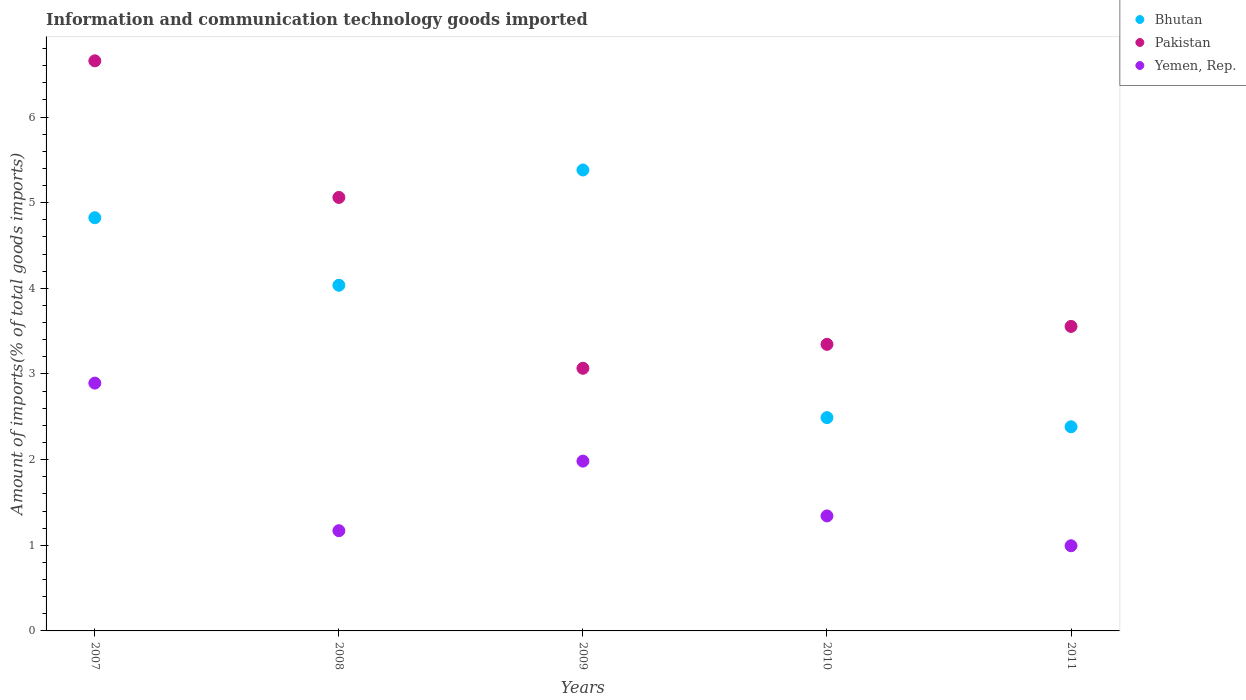What is the amount of goods imported in Yemen, Rep. in 2011?
Give a very brief answer. 0.99. Across all years, what is the maximum amount of goods imported in Bhutan?
Offer a terse response. 5.38. Across all years, what is the minimum amount of goods imported in Yemen, Rep.?
Your response must be concise. 0.99. In which year was the amount of goods imported in Bhutan minimum?
Your response must be concise. 2011. What is the total amount of goods imported in Yemen, Rep. in the graph?
Your response must be concise. 8.38. What is the difference between the amount of goods imported in Bhutan in 2008 and that in 2010?
Make the answer very short. 1.55. What is the difference between the amount of goods imported in Yemen, Rep. in 2008 and the amount of goods imported in Pakistan in 2010?
Keep it short and to the point. -2.18. What is the average amount of goods imported in Bhutan per year?
Make the answer very short. 3.82. In the year 2007, what is the difference between the amount of goods imported in Yemen, Rep. and amount of goods imported in Pakistan?
Give a very brief answer. -3.76. In how many years, is the amount of goods imported in Pakistan greater than 1 %?
Make the answer very short. 5. What is the ratio of the amount of goods imported in Yemen, Rep. in 2007 to that in 2008?
Make the answer very short. 2.47. Is the difference between the amount of goods imported in Yemen, Rep. in 2007 and 2011 greater than the difference between the amount of goods imported in Pakistan in 2007 and 2011?
Offer a very short reply. No. What is the difference between the highest and the second highest amount of goods imported in Bhutan?
Make the answer very short. 0.56. What is the difference between the highest and the lowest amount of goods imported in Yemen, Rep.?
Your response must be concise. 1.9. In how many years, is the amount of goods imported in Pakistan greater than the average amount of goods imported in Pakistan taken over all years?
Give a very brief answer. 2. Is the sum of the amount of goods imported in Pakistan in 2008 and 2011 greater than the maximum amount of goods imported in Bhutan across all years?
Ensure brevity in your answer.  Yes. Does the amount of goods imported in Pakistan monotonically increase over the years?
Your answer should be very brief. No. Is the amount of goods imported in Bhutan strictly greater than the amount of goods imported in Yemen, Rep. over the years?
Offer a terse response. Yes. Where does the legend appear in the graph?
Provide a succinct answer. Top right. How are the legend labels stacked?
Provide a succinct answer. Vertical. What is the title of the graph?
Give a very brief answer. Information and communication technology goods imported. What is the label or title of the X-axis?
Ensure brevity in your answer.  Years. What is the label or title of the Y-axis?
Ensure brevity in your answer.  Amount of imports(% of total goods imports). What is the Amount of imports(% of total goods imports) of Bhutan in 2007?
Keep it short and to the point. 4.82. What is the Amount of imports(% of total goods imports) of Pakistan in 2007?
Give a very brief answer. 6.66. What is the Amount of imports(% of total goods imports) in Yemen, Rep. in 2007?
Your response must be concise. 2.89. What is the Amount of imports(% of total goods imports) in Bhutan in 2008?
Provide a short and direct response. 4.04. What is the Amount of imports(% of total goods imports) of Pakistan in 2008?
Your answer should be very brief. 5.06. What is the Amount of imports(% of total goods imports) of Yemen, Rep. in 2008?
Provide a succinct answer. 1.17. What is the Amount of imports(% of total goods imports) of Bhutan in 2009?
Offer a terse response. 5.38. What is the Amount of imports(% of total goods imports) in Pakistan in 2009?
Make the answer very short. 3.07. What is the Amount of imports(% of total goods imports) of Yemen, Rep. in 2009?
Keep it short and to the point. 1.98. What is the Amount of imports(% of total goods imports) of Bhutan in 2010?
Your answer should be very brief. 2.49. What is the Amount of imports(% of total goods imports) in Pakistan in 2010?
Your answer should be compact. 3.35. What is the Amount of imports(% of total goods imports) of Yemen, Rep. in 2010?
Give a very brief answer. 1.34. What is the Amount of imports(% of total goods imports) in Bhutan in 2011?
Make the answer very short. 2.38. What is the Amount of imports(% of total goods imports) of Pakistan in 2011?
Offer a terse response. 3.56. What is the Amount of imports(% of total goods imports) of Yemen, Rep. in 2011?
Provide a short and direct response. 0.99. Across all years, what is the maximum Amount of imports(% of total goods imports) of Bhutan?
Offer a very short reply. 5.38. Across all years, what is the maximum Amount of imports(% of total goods imports) in Pakistan?
Make the answer very short. 6.66. Across all years, what is the maximum Amount of imports(% of total goods imports) of Yemen, Rep.?
Make the answer very short. 2.89. Across all years, what is the minimum Amount of imports(% of total goods imports) of Bhutan?
Offer a very short reply. 2.38. Across all years, what is the minimum Amount of imports(% of total goods imports) in Pakistan?
Provide a short and direct response. 3.07. Across all years, what is the minimum Amount of imports(% of total goods imports) in Yemen, Rep.?
Provide a succinct answer. 0.99. What is the total Amount of imports(% of total goods imports) of Bhutan in the graph?
Offer a terse response. 19.12. What is the total Amount of imports(% of total goods imports) in Pakistan in the graph?
Give a very brief answer. 21.69. What is the total Amount of imports(% of total goods imports) of Yemen, Rep. in the graph?
Offer a very short reply. 8.38. What is the difference between the Amount of imports(% of total goods imports) of Bhutan in 2007 and that in 2008?
Keep it short and to the point. 0.79. What is the difference between the Amount of imports(% of total goods imports) of Pakistan in 2007 and that in 2008?
Your answer should be compact. 1.6. What is the difference between the Amount of imports(% of total goods imports) in Yemen, Rep. in 2007 and that in 2008?
Provide a succinct answer. 1.72. What is the difference between the Amount of imports(% of total goods imports) of Bhutan in 2007 and that in 2009?
Ensure brevity in your answer.  -0.56. What is the difference between the Amount of imports(% of total goods imports) of Pakistan in 2007 and that in 2009?
Ensure brevity in your answer.  3.59. What is the difference between the Amount of imports(% of total goods imports) in Yemen, Rep. in 2007 and that in 2009?
Your answer should be very brief. 0.91. What is the difference between the Amount of imports(% of total goods imports) in Bhutan in 2007 and that in 2010?
Your response must be concise. 2.33. What is the difference between the Amount of imports(% of total goods imports) of Pakistan in 2007 and that in 2010?
Provide a succinct answer. 3.31. What is the difference between the Amount of imports(% of total goods imports) in Yemen, Rep. in 2007 and that in 2010?
Give a very brief answer. 1.55. What is the difference between the Amount of imports(% of total goods imports) of Bhutan in 2007 and that in 2011?
Give a very brief answer. 2.44. What is the difference between the Amount of imports(% of total goods imports) in Pakistan in 2007 and that in 2011?
Provide a short and direct response. 3.1. What is the difference between the Amount of imports(% of total goods imports) of Yemen, Rep. in 2007 and that in 2011?
Provide a succinct answer. 1.9. What is the difference between the Amount of imports(% of total goods imports) of Bhutan in 2008 and that in 2009?
Keep it short and to the point. -1.35. What is the difference between the Amount of imports(% of total goods imports) in Pakistan in 2008 and that in 2009?
Offer a terse response. 1.99. What is the difference between the Amount of imports(% of total goods imports) in Yemen, Rep. in 2008 and that in 2009?
Offer a very short reply. -0.81. What is the difference between the Amount of imports(% of total goods imports) of Bhutan in 2008 and that in 2010?
Your response must be concise. 1.55. What is the difference between the Amount of imports(% of total goods imports) in Pakistan in 2008 and that in 2010?
Make the answer very short. 1.72. What is the difference between the Amount of imports(% of total goods imports) of Yemen, Rep. in 2008 and that in 2010?
Your answer should be very brief. -0.17. What is the difference between the Amount of imports(% of total goods imports) in Bhutan in 2008 and that in 2011?
Provide a succinct answer. 1.65. What is the difference between the Amount of imports(% of total goods imports) of Pakistan in 2008 and that in 2011?
Make the answer very short. 1.51. What is the difference between the Amount of imports(% of total goods imports) in Yemen, Rep. in 2008 and that in 2011?
Offer a terse response. 0.18. What is the difference between the Amount of imports(% of total goods imports) in Bhutan in 2009 and that in 2010?
Keep it short and to the point. 2.89. What is the difference between the Amount of imports(% of total goods imports) in Pakistan in 2009 and that in 2010?
Offer a terse response. -0.28. What is the difference between the Amount of imports(% of total goods imports) in Yemen, Rep. in 2009 and that in 2010?
Offer a very short reply. 0.64. What is the difference between the Amount of imports(% of total goods imports) in Bhutan in 2009 and that in 2011?
Offer a terse response. 3. What is the difference between the Amount of imports(% of total goods imports) in Pakistan in 2009 and that in 2011?
Your answer should be very brief. -0.49. What is the difference between the Amount of imports(% of total goods imports) of Bhutan in 2010 and that in 2011?
Your response must be concise. 0.11. What is the difference between the Amount of imports(% of total goods imports) in Pakistan in 2010 and that in 2011?
Provide a succinct answer. -0.21. What is the difference between the Amount of imports(% of total goods imports) in Yemen, Rep. in 2010 and that in 2011?
Your answer should be compact. 0.35. What is the difference between the Amount of imports(% of total goods imports) in Bhutan in 2007 and the Amount of imports(% of total goods imports) in Pakistan in 2008?
Your answer should be compact. -0.24. What is the difference between the Amount of imports(% of total goods imports) in Bhutan in 2007 and the Amount of imports(% of total goods imports) in Yemen, Rep. in 2008?
Your answer should be compact. 3.65. What is the difference between the Amount of imports(% of total goods imports) of Pakistan in 2007 and the Amount of imports(% of total goods imports) of Yemen, Rep. in 2008?
Provide a succinct answer. 5.49. What is the difference between the Amount of imports(% of total goods imports) of Bhutan in 2007 and the Amount of imports(% of total goods imports) of Pakistan in 2009?
Your answer should be compact. 1.76. What is the difference between the Amount of imports(% of total goods imports) of Bhutan in 2007 and the Amount of imports(% of total goods imports) of Yemen, Rep. in 2009?
Ensure brevity in your answer.  2.84. What is the difference between the Amount of imports(% of total goods imports) in Pakistan in 2007 and the Amount of imports(% of total goods imports) in Yemen, Rep. in 2009?
Give a very brief answer. 4.67. What is the difference between the Amount of imports(% of total goods imports) in Bhutan in 2007 and the Amount of imports(% of total goods imports) in Pakistan in 2010?
Provide a short and direct response. 1.48. What is the difference between the Amount of imports(% of total goods imports) in Bhutan in 2007 and the Amount of imports(% of total goods imports) in Yemen, Rep. in 2010?
Your answer should be compact. 3.48. What is the difference between the Amount of imports(% of total goods imports) of Pakistan in 2007 and the Amount of imports(% of total goods imports) of Yemen, Rep. in 2010?
Your answer should be compact. 5.31. What is the difference between the Amount of imports(% of total goods imports) of Bhutan in 2007 and the Amount of imports(% of total goods imports) of Pakistan in 2011?
Ensure brevity in your answer.  1.27. What is the difference between the Amount of imports(% of total goods imports) in Bhutan in 2007 and the Amount of imports(% of total goods imports) in Yemen, Rep. in 2011?
Keep it short and to the point. 3.83. What is the difference between the Amount of imports(% of total goods imports) in Pakistan in 2007 and the Amount of imports(% of total goods imports) in Yemen, Rep. in 2011?
Make the answer very short. 5.66. What is the difference between the Amount of imports(% of total goods imports) in Bhutan in 2008 and the Amount of imports(% of total goods imports) in Pakistan in 2009?
Ensure brevity in your answer.  0.97. What is the difference between the Amount of imports(% of total goods imports) of Bhutan in 2008 and the Amount of imports(% of total goods imports) of Yemen, Rep. in 2009?
Make the answer very short. 2.05. What is the difference between the Amount of imports(% of total goods imports) in Pakistan in 2008 and the Amount of imports(% of total goods imports) in Yemen, Rep. in 2009?
Provide a succinct answer. 3.08. What is the difference between the Amount of imports(% of total goods imports) in Bhutan in 2008 and the Amount of imports(% of total goods imports) in Pakistan in 2010?
Your answer should be very brief. 0.69. What is the difference between the Amount of imports(% of total goods imports) in Bhutan in 2008 and the Amount of imports(% of total goods imports) in Yemen, Rep. in 2010?
Your response must be concise. 2.69. What is the difference between the Amount of imports(% of total goods imports) in Pakistan in 2008 and the Amount of imports(% of total goods imports) in Yemen, Rep. in 2010?
Your response must be concise. 3.72. What is the difference between the Amount of imports(% of total goods imports) in Bhutan in 2008 and the Amount of imports(% of total goods imports) in Pakistan in 2011?
Ensure brevity in your answer.  0.48. What is the difference between the Amount of imports(% of total goods imports) in Bhutan in 2008 and the Amount of imports(% of total goods imports) in Yemen, Rep. in 2011?
Give a very brief answer. 3.04. What is the difference between the Amount of imports(% of total goods imports) of Pakistan in 2008 and the Amount of imports(% of total goods imports) of Yemen, Rep. in 2011?
Provide a succinct answer. 4.07. What is the difference between the Amount of imports(% of total goods imports) of Bhutan in 2009 and the Amount of imports(% of total goods imports) of Pakistan in 2010?
Offer a terse response. 2.04. What is the difference between the Amount of imports(% of total goods imports) in Bhutan in 2009 and the Amount of imports(% of total goods imports) in Yemen, Rep. in 2010?
Provide a succinct answer. 4.04. What is the difference between the Amount of imports(% of total goods imports) of Pakistan in 2009 and the Amount of imports(% of total goods imports) of Yemen, Rep. in 2010?
Make the answer very short. 1.72. What is the difference between the Amount of imports(% of total goods imports) of Bhutan in 2009 and the Amount of imports(% of total goods imports) of Pakistan in 2011?
Provide a short and direct response. 1.83. What is the difference between the Amount of imports(% of total goods imports) in Bhutan in 2009 and the Amount of imports(% of total goods imports) in Yemen, Rep. in 2011?
Provide a short and direct response. 4.39. What is the difference between the Amount of imports(% of total goods imports) in Pakistan in 2009 and the Amount of imports(% of total goods imports) in Yemen, Rep. in 2011?
Your answer should be very brief. 2.07. What is the difference between the Amount of imports(% of total goods imports) in Bhutan in 2010 and the Amount of imports(% of total goods imports) in Pakistan in 2011?
Your answer should be very brief. -1.06. What is the difference between the Amount of imports(% of total goods imports) in Bhutan in 2010 and the Amount of imports(% of total goods imports) in Yemen, Rep. in 2011?
Offer a very short reply. 1.5. What is the difference between the Amount of imports(% of total goods imports) of Pakistan in 2010 and the Amount of imports(% of total goods imports) of Yemen, Rep. in 2011?
Your answer should be very brief. 2.35. What is the average Amount of imports(% of total goods imports) in Bhutan per year?
Give a very brief answer. 3.82. What is the average Amount of imports(% of total goods imports) in Pakistan per year?
Make the answer very short. 4.34. What is the average Amount of imports(% of total goods imports) in Yemen, Rep. per year?
Provide a short and direct response. 1.68. In the year 2007, what is the difference between the Amount of imports(% of total goods imports) in Bhutan and Amount of imports(% of total goods imports) in Pakistan?
Offer a terse response. -1.83. In the year 2007, what is the difference between the Amount of imports(% of total goods imports) of Bhutan and Amount of imports(% of total goods imports) of Yemen, Rep.?
Your answer should be compact. 1.93. In the year 2007, what is the difference between the Amount of imports(% of total goods imports) of Pakistan and Amount of imports(% of total goods imports) of Yemen, Rep.?
Offer a very short reply. 3.76. In the year 2008, what is the difference between the Amount of imports(% of total goods imports) in Bhutan and Amount of imports(% of total goods imports) in Pakistan?
Your answer should be very brief. -1.03. In the year 2008, what is the difference between the Amount of imports(% of total goods imports) of Bhutan and Amount of imports(% of total goods imports) of Yemen, Rep.?
Provide a short and direct response. 2.87. In the year 2008, what is the difference between the Amount of imports(% of total goods imports) of Pakistan and Amount of imports(% of total goods imports) of Yemen, Rep.?
Make the answer very short. 3.89. In the year 2009, what is the difference between the Amount of imports(% of total goods imports) in Bhutan and Amount of imports(% of total goods imports) in Pakistan?
Provide a succinct answer. 2.32. In the year 2009, what is the difference between the Amount of imports(% of total goods imports) of Bhutan and Amount of imports(% of total goods imports) of Yemen, Rep.?
Offer a very short reply. 3.4. In the year 2009, what is the difference between the Amount of imports(% of total goods imports) in Pakistan and Amount of imports(% of total goods imports) in Yemen, Rep.?
Provide a short and direct response. 1.08. In the year 2010, what is the difference between the Amount of imports(% of total goods imports) of Bhutan and Amount of imports(% of total goods imports) of Pakistan?
Make the answer very short. -0.86. In the year 2010, what is the difference between the Amount of imports(% of total goods imports) in Bhutan and Amount of imports(% of total goods imports) in Yemen, Rep.?
Keep it short and to the point. 1.15. In the year 2010, what is the difference between the Amount of imports(% of total goods imports) in Pakistan and Amount of imports(% of total goods imports) in Yemen, Rep.?
Your answer should be compact. 2. In the year 2011, what is the difference between the Amount of imports(% of total goods imports) of Bhutan and Amount of imports(% of total goods imports) of Pakistan?
Ensure brevity in your answer.  -1.17. In the year 2011, what is the difference between the Amount of imports(% of total goods imports) of Bhutan and Amount of imports(% of total goods imports) of Yemen, Rep.?
Offer a very short reply. 1.39. In the year 2011, what is the difference between the Amount of imports(% of total goods imports) of Pakistan and Amount of imports(% of total goods imports) of Yemen, Rep.?
Your response must be concise. 2.56. What is the ratio of the Amount of imports(% of total goods imports) of Bhutan in 2007 to that in 2008?
Provide a succinct answer. 1.2. What is the ratio of the Amount of imports(% of total goods imports) in Pakistan in 2007 to that in 2008?
Give a very brief answer. 1.32. What is the ratio of the Amount of imports(% of total goods imports) in Yemen, Rep. in 2007 to that in 2008?
Provide a succinct answer. 2.47. What is the ratio of the Amount of imports(% of total goods imports) of Bhutan in 2007 to that in 2009?
Offer a terse response. 0.9. What is the ratio of the Amount of imports(% of total goods imports) of Pakistan in 2007 to that in 2009?
Offer a terse response. 2.17. What is the ratio of the Amount of imports(% of total goods imports) of Yemen, Rep. in 2007 to that in 2009?
Provide a short and direct response. 1.46. What is the ratio of the Amount of imports(% of total goods imports) in Bhutan in 2007 to that in 2010?
Your answer should be compact. 1.94. What is the ratio of the Amount of imports(% of total goods imports) of Pakistan in 2007 to that in 2010?
Your answer should be very brief. 1.99. What is the ratio of the Amount of imports(% of total goods imports) of Yemen, Rep. in 2007 to that in 2010?
Offer a very short reply. 2.16. What is the ratio of the Amount of imports(% of total goods imports) in Bhutan in 2007 to that in 2011?
Ensure brevity in your answer.  2.02. What is the ratio of the Amount of imports(% of total goods imports) of Pakistan in 2007 to that in 2011?
Your answer should be very brief. 1.87. What is the ratio of the Amount of imports(% of total goods imports) of Yemen, Rep. in 2007 to that in 2011?
Provide a succinct answer. 2.91. What is the ratio of the Amount of imports(% of total goods imports) in Bhutan in 2008 to that in 2009?
Give a very brief answer. 0.75. What is the ratio of the Amount of imports(% of total goods imports) in Pakistan in 2008 to that in 2009?
Give a very brief answer. 1.65. What is the ratio of the Amount of imports(% of total goods imports) in Yemen, Rep. in 2008 to that in 2009?
Your answer should be compact. 0.59. What is the ratio of the Amount of imports(% of total goods imports) in Bhutan in 2008 to that in 2010?
Your answer should be compact. 1.62. What is the ratio of the Amount of imports(% of total goods imports) of Pakistan in 2008 to that in 2010?
Offer a terse response. 1.51. What is the ratio of the Amount of imports(% of total goods imports) in Yemen, Rep. in 2008 to that in 2010?
Keep it short and to the point. 0.87. What is the ratio of the Amount of imports(% of total goods imports) in Bhutan in 2008 to that in 2011?
Provide a short and direct response. 1.69. What is the ratio of the Amount of imports(% of total goods imports) in Pakistan in 2008 to that in 2011?
Offer a very short reply. 1.42. What is the ratio of the Amount of imports(% of total goods imports) of Yemen, Rep. in 2008 to that in 2011?
Ensure brevity in your answer.  1.18. What is the ratio of the Amount of imports(% of total goods imports) in Bhutan in 2009 to that in 2010?
Provide a short and direct response. 2.16. What is the ratio of the Amount of imports(% of total goods imports) of Pakistan in 2009 to that in 2010?
Offer a very short reply. 0.92. What is the ratio of the Amount of imports(% of total goods imports) in Yemen, Rep. in 2009 to that in 2010?
Give a very brief answer. 1.48. What is the ratio of the Amount of imports(% of total goods imports) of Bhutan in 2009 to that in 2011?
Provide a short and direct response. 2.26. What is the ratio of the Amount of imports(% of total goods imports) in Pakistan in 2009 to that in 2011?
Offer a terse response. 0.86. What is the ratio of the Amount of imports(% of total goods imports) in Yemen, Rep. in 2009 to that in 2011?
Make the answer very short. 1.99. What is the ratio of the Amount of imports(% of total goods imports) of Bhutan in 2010 to that in 2011?
Your answer should be very brief. 1.04. What is the ratio of the Amount of imports(% of total goods imports) in Pakistan in 2010 to that in 2011?
Your response must be concise. 0.94. What is the ratio of the Amount of imports(% of total goods imports) of Yemen, Rep. in 2010 to that in 2011?
Offer a terse response. 1.35. What is the difference between the highest and the second highest Amount of imports(% of total goods imports) in Bhutan?
Offer a very short reply. 0.56. What is the difference between the highest and the second highest Amount of imports(% of total goods imports) of Pakistan?
Provide a succinct answer. 1.6. What is the difference between the highest and the second highest Amount of imports(% of total goods imports) of Yemen, Rep.?
Your answer should be compact. 0.91. What is the difference between the highest and the lowest Amount of imports(% of total goods imports) in Bhutan?
Your response must be concise. 3. What is the difference between the highest and the lowest Amount of imports(% of total goods imports) in Pakistan?
Make the answer very short. 3.59. What is the difference between the highest and the lowest Amount of imports(% of total goods imports) in Yemen, Rep.?
Ensure brevity in your answer.  1.9. 